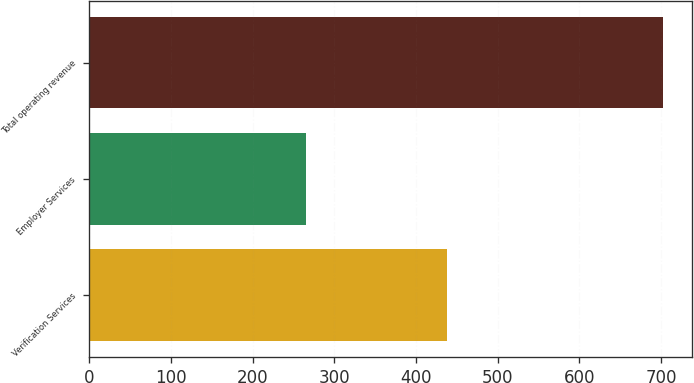Convert chart. <chart><loc_0><loc_0><loc_500><loc_500><bar_chart><fcel>Verification Services<fcel>Employer Services<fcel>Total operating revenue<nl><fcel>437.3<fcel>264.9<fcel>702.2<nl></chart> 